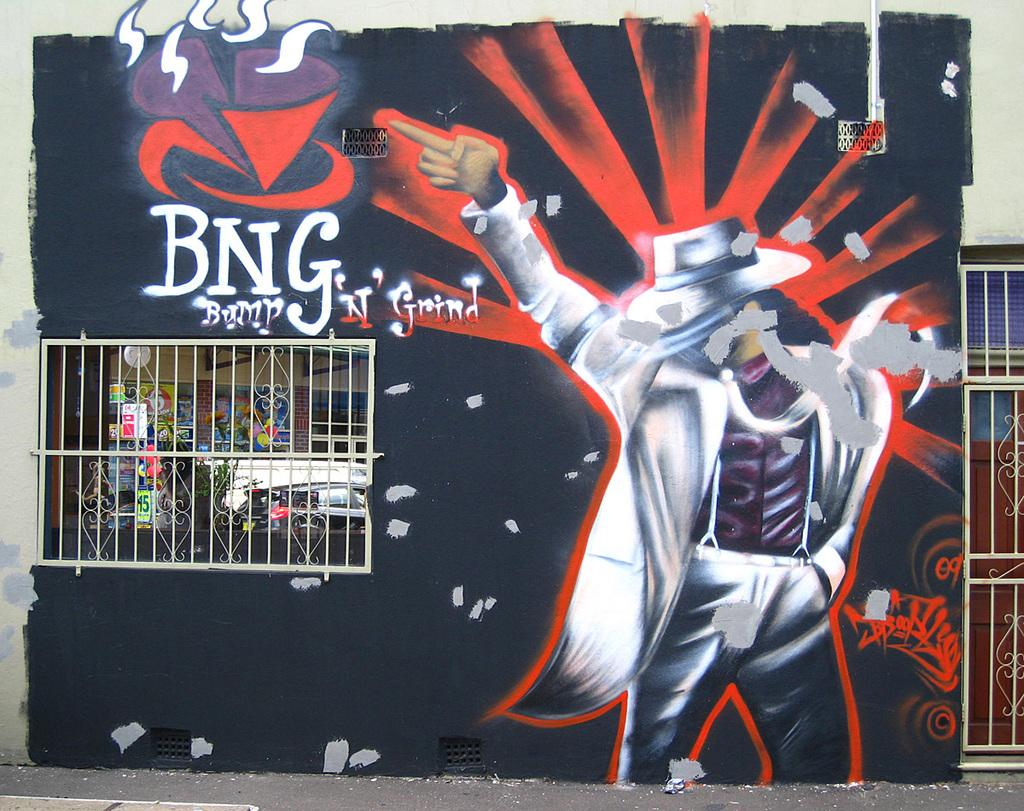<image>
Present a compact description of the photo's key features. Grafitti drawing of Michael Jackson on a wall and the letters BNG right next to it. 